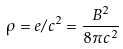<formula> <loc_0><loc_0><loc_500><loc_500>\rho = e / c ^ { 2 } = \frac { B ^ { 2 } } { 8 \pi c ^ { 2 } }</formula> 